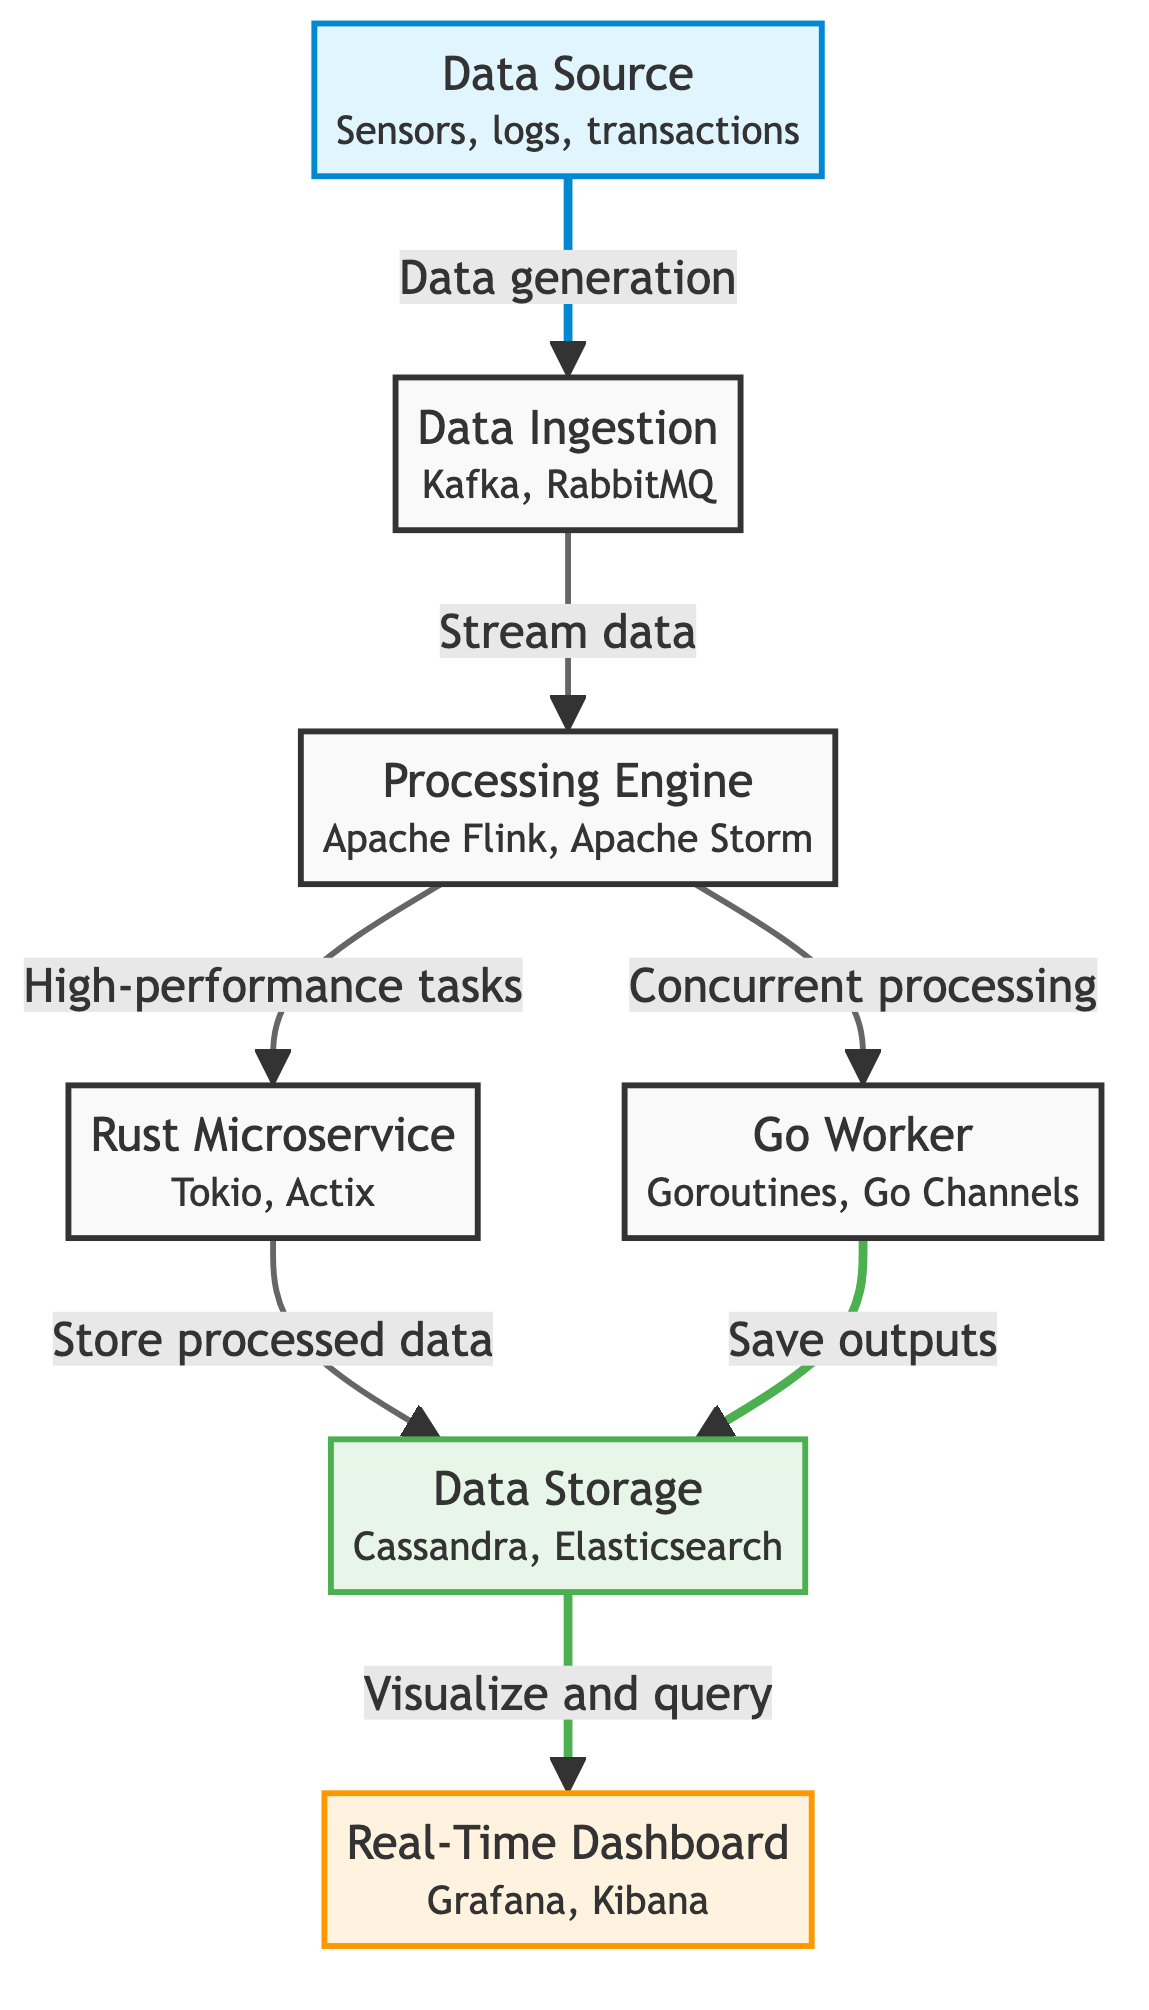What is the main data source type shown in the diagram? The diagram labels the main data source as "Data Source," which includes entities such as sensors, logs, or transactions.
Answer: Data Source How many nodes are present in the network diagram? By counting the nodes listed in the diagram, there are a total of seven distinct nodes: Data Source, Data Ingestion, Processing Engine, Rust Microservice, Go Worker, Data Storage, and Real-Time Dashboard.
Answer: Seven What technologies are used for data ingestion? The node labeled "Data Ingestion" includes two technologies: Kafka and RabbitMQ, which are typically used for real-time data ingestion.
Answer: Kafka, RabbitMQ Which node is responsible for storing processed data from both Rust and Go? The diagram shows that both the Rust Microservice and Go Worker have edges leading to the Data Storage node, which is the responsible entity for storing processed data.
Answer: Data Storage What type of tasks does the Processing Engine delegate to the Rust Microservice? The Processing Engine is noted in the diagram to delegate "High-performance tasks" specifically to the Rust Microservice, as indicated by the directed edge connecting them.
Answer: High-performance tasks Which technologies power the Real-Time Dashboard? The Real-Time Dashboard node in the diagram is associated with technologies Grafana and Kibana, which are commonly used for visualization and querying of real-time processed data.
Answer: Grafana, Kibana What is the relationship between the Data Storage and Real-Time Dashboard nodes? The edge from Data Storage to Real-Time Dashboard indicates that the stored processed data is used to "Visualize and query" in real-time via the dashboard, showing a direct relationship in the flow of information.
Answer: Visualize and query Which microservice implementation is highlighted for high-performance processing? The diagram specifically highlights the Rust Microservice as the implementation used for high-performance processing within the described data processing pipeline.
Answer: Rust Microservice How does the Processing Engine interact with the Go Worker? The Processing Engine connects directly to the Go Worker with an edge indicating that it handles "Concurrent processing" tasks, making the interaction focused on concurrency in data handling.
Answer: Concurrent processing 